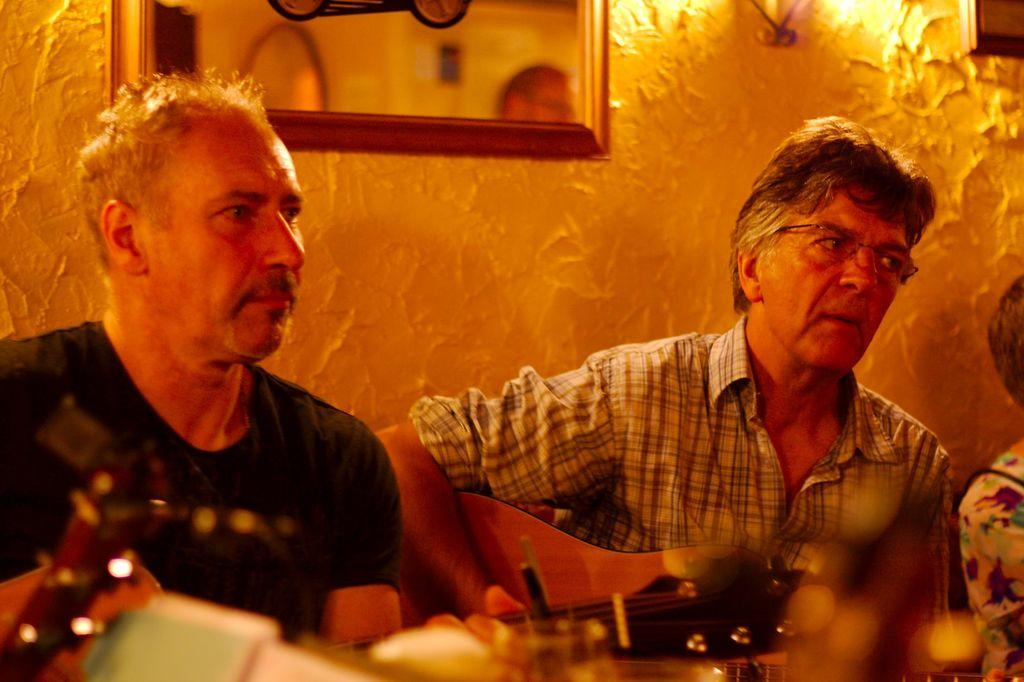How many people are in the image? There are two people in the image. Can you describe any specific features of one of the people? One of the people is wearing spectacles. What is one of the people holding in the image? One of the people is holding an unspecified object. What type of bomb is visible in the image? There is no bomb present in the image. What color is the underwear being worn by one of the people in the image? There is no information about the color or presence of underwear in the image. How does one of the people blow out a candle in the image? There is no candle or indication of blowing in the image. 